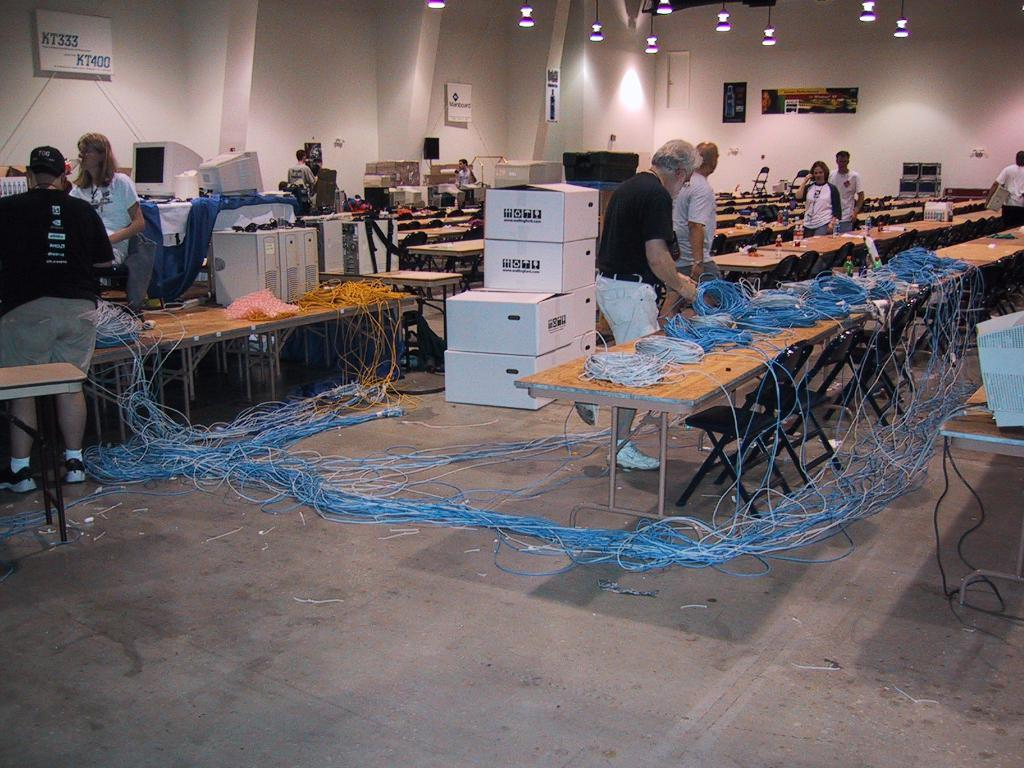How many people are in the image? There are two persons standing in the image. What is present on the table in the image? There is a wire and objects on the table in the image. What can be seen in the background of the image? There is a wall in the image. What type of lighting is visible in the image? There are lights in the image. What type of ornament is hanging from the wire on the table? There is no ornament hanging from the wire on the table in the image. What is being offered by the persons in the image? The image does not provide any information about an offer being made by the persons. 